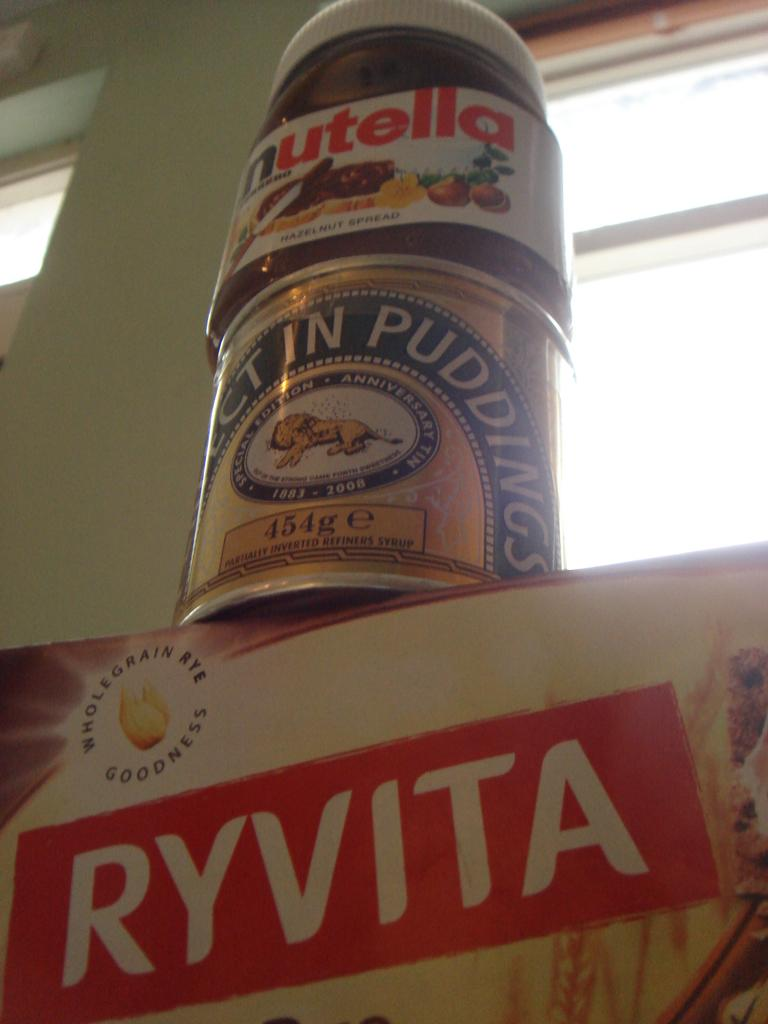<image>
Describe the image concisely. A jar of Nutella sitting on top of a can of pudding sitting on a box. 